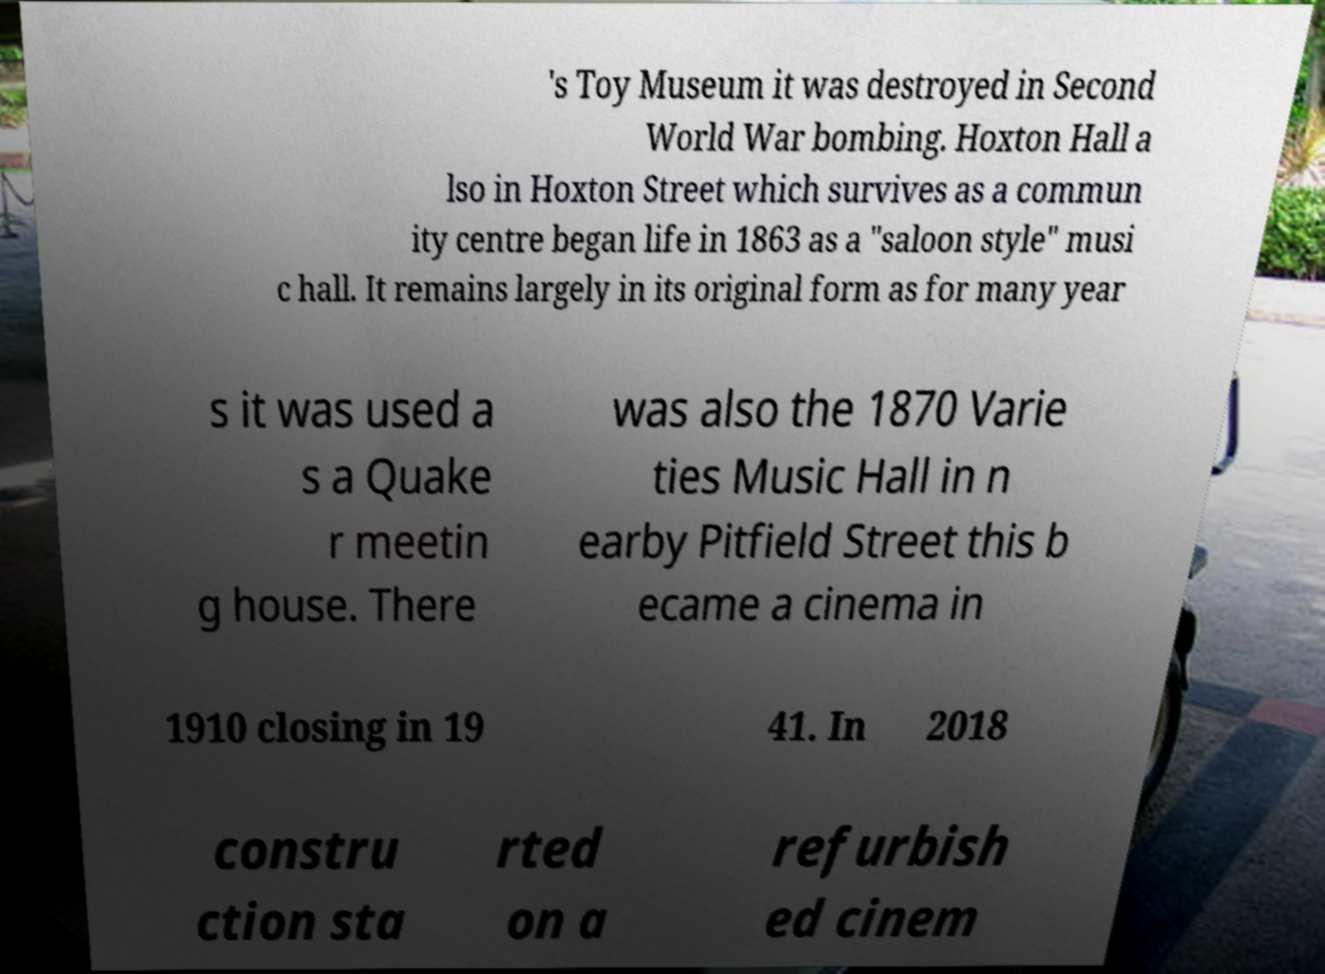Please read and relay the text visible in this image. What does it say? 's Toy Museum it was destroyed in Second World War bombing. Hoxton Hall a lso in Hoxton Street which survives as a commun ity centre began life in 1863 as a "saloon style" musi c hall. It remains largely in its original form as for many year s it was used a s a Quake r meetin g house. There was also the 1870 Varie ties Music Hall in n earby Pitfield Street this b ecame a cinema in 1910 closing in 19 41. In 2018 constru ction sta rted on a refurbish ed cinem 